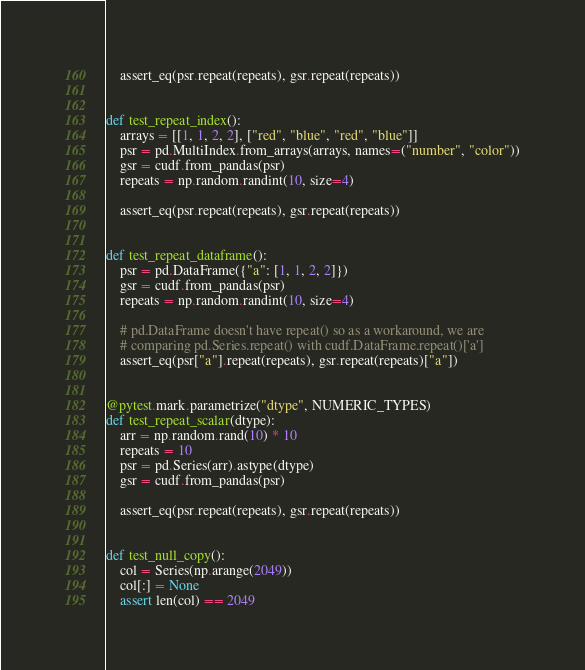<code> <loc_0><loc_0><loc_500><loc_500><_Python_>
    assert_eq(psr.repeat(repeats), gsr.repeat(repeats))


def test_repeat_index():
    arrays = [[1, 1, 2, 2], ["red", "blue", "red", "blue"]]
    psr = pd.MultiIndex.from_arrays(arrays, names=("number", "color"))
    gsr = cudf.from_pandas(psr)
    repeats = np.random.randint(10, size=4)

    assert_eq(psr.repeat(repeats), gsr.repeat(repeats))


def test_repeat_dataframe():
    psr = pd.DataFrame({"a": [1, 1, 2, 2]})
    gsr = cudf.from_pandas(psr)
    repeats = np.random.randint(10, size=4)

    # pd.DataFrame doesn't have repeat() so as a workaround, we are
    # comparing pd.Series.repeat() with cudf.DataFrame.repeat()['a']
    assert_eq(psr["a"].repeat(repeats), gsr.repeat(repeats)["a"])


@pytest.mark.parametrize("dtype", NUMERIC_TYPES)
def test_repeat_scalar(dtype):
    arr = np.random.rand(10) * 10
    repeats = 10
    psr = pd.Series(arr).astype(dtype)
    gsr = cudf.from_pandas(psr)

    assert_eq(psr.repeat(repeats), gsr.repeat(repeats))


def test_null_copy():
    col = Series(np.arange(2049))
    col[:] = None
    assert len(col) == 2049
</code> 